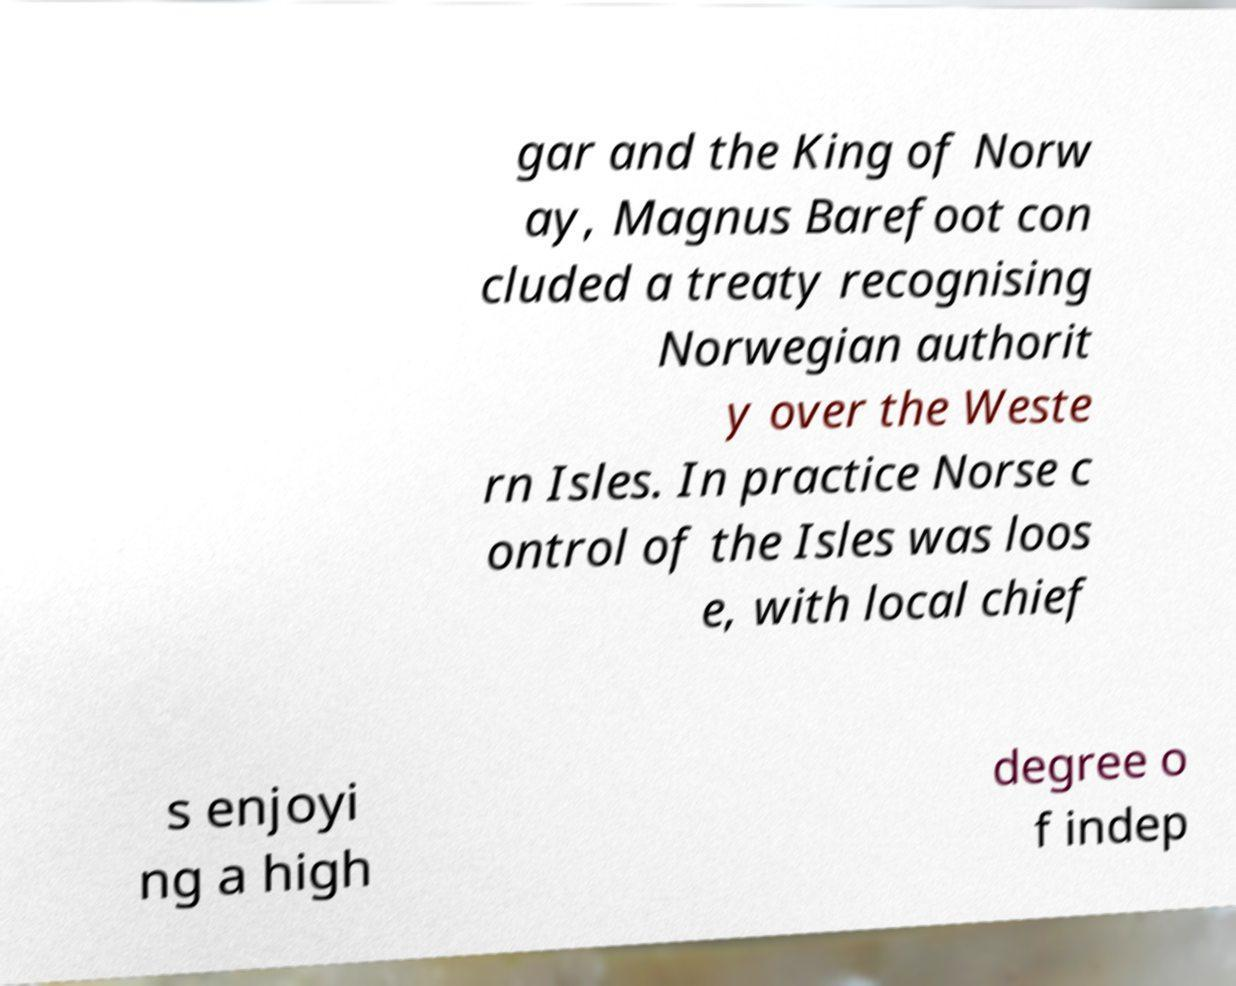I need the written content from this picture converted into text. Can you do that? gar and the King of Norw ay, Magnus Barefoot con cluded a treaty recognising Norwegian authorit y over the Weste rn Isles. In practice Norse c ontrol of the Isles was loos e, with local chief s enjoyi ng a high degree o f indep 